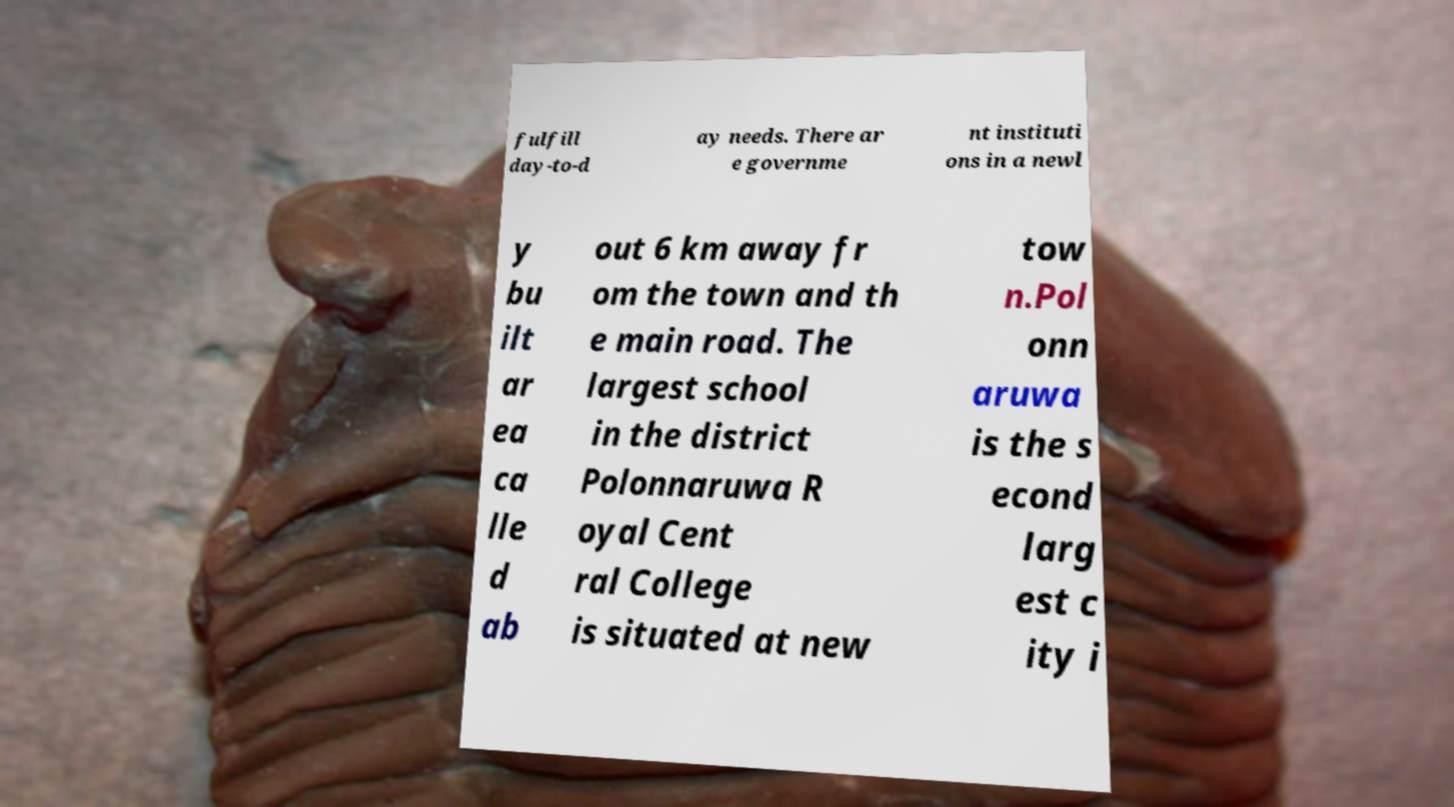What messages or text are displayed in this image? I need them in a readable, typed format. fulfill day-to-d ay needs. There ar e governme nt instituti ons in a newl y bu ilt ar ea ca lle d ab out 6 km away fr om the town and th e main road. The largest school in the district Polonnaruwa R oyal Cent ral College is situated at new tow n.Pol onn aruwa is the s econd larg est c ity i 